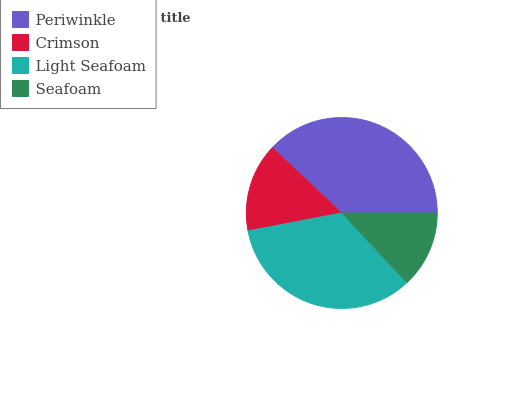Is Seafoam the minimum?
Answer yes or no. Yes. Is Periwinkle the maximum?
Answer yes or no. Yes. Is Crimson the minimum?
Answer yes or no. No. Is Crimson the maximum?
Answer yes or no. No. Is Periwinkle greater than Crimson?
Answer yes or no. Yes. Is Crimson less than Periwinkle?
Answer yes or no. Yes. Is Crimson greater than Periwinkle?
Answer yes or no. No. Is Periwinkle less than Crimson?
Answer yes or no. No. Is Light Seafoam the high median?
Answer yes or no. Yes. Is Crimson the low median?
Answer yes or no. Yes. Is Periwinkle the high median?
Answer yes or no. No. Is Seafoam the low median?
Answer yes or no. No. 